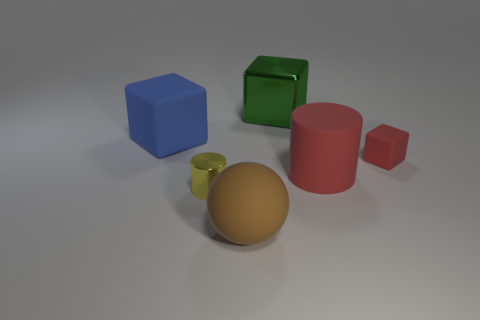Subtract all brown blocks. Subtract all red cylinders. How many blocks are left? 3 Add 2 big rubber objects. How many objects exist? 8 Subtract all balls. How many objects are left? 5 Subtract 0 purple spheres. How many objects are left? 6 Subtract all big red matte blocks. Subtract all brown things. How many objects are left? 5 Add 2 rubber balls. How many rubber balls are left? 3 Add 3 tiny yellow objects. How many tiny yellow objects exist? 4 